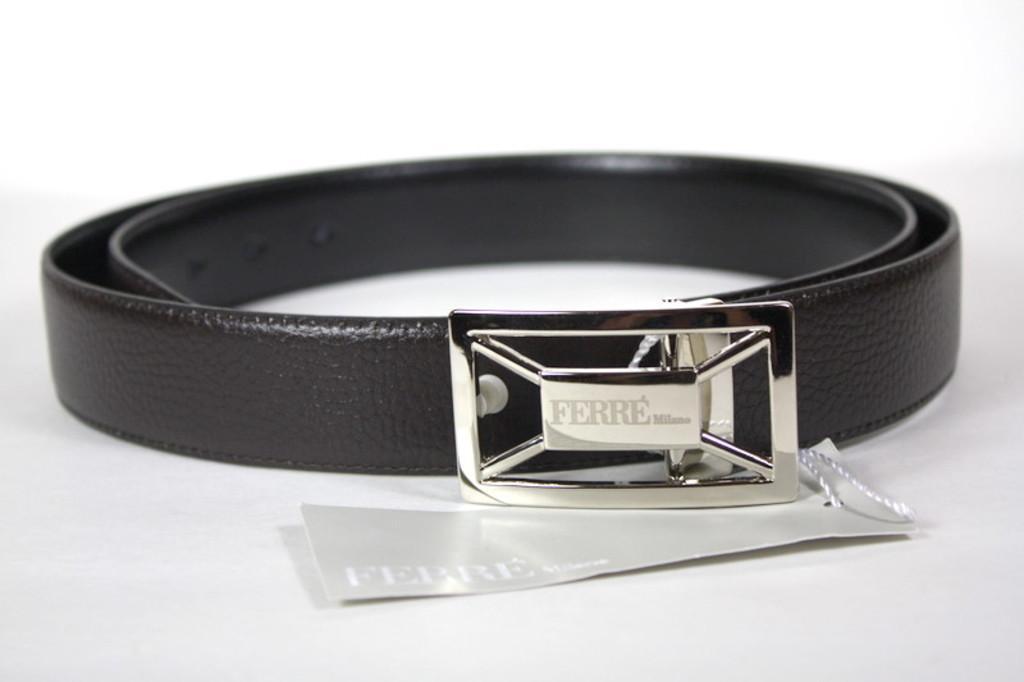Describe this image in one or two sentences. In this picture we can see a leather belt which is black in color and we can see a tag. Remaining portion of the picture is in white color. 